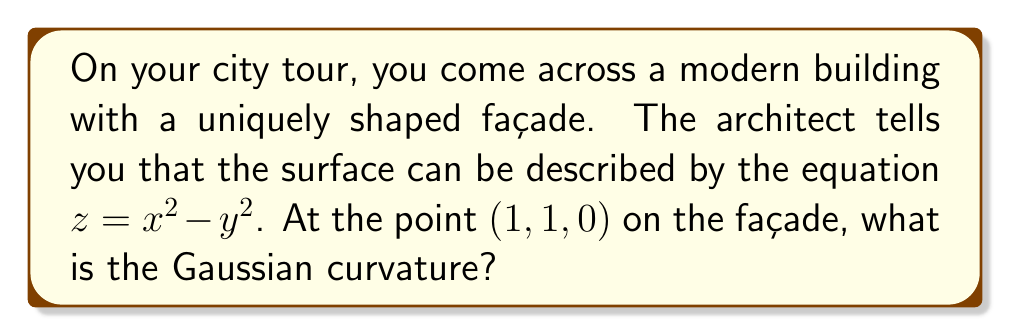Solve this math problem. To find the Gaussian curvature of the surface at the point (1, 1, 0), we'll follow these steps:

1) The surface is given by $z = x^2 - y^2$. Let's call this function $f(x,y)$.

2) We need to calculate the first and second partial derivatives:
   $f_x = 2x$
   $f_y = -2y$
   $f_{xx} = 2$
   $f_{yy} = -2$
   $f_{xy} = f_{yx} = 0$

3) The Gaussian curvature K is given by:
   $$K = \frac{f_{xx}f_{yy} - f_{xy}^2}{(1 + f_x^2 + f_y^2)^2}$$

4) Let's calculate the denominator first:
   At (1, 1, 0): $f_x = 2$ and $f_y = -2$
   $(1 + f_x^2 + f_y^2)^2 = (1 + 2^2 + (-2)^2)^2 = (1 + 4 + 4)^2 = 9^2 = 81$

5) Now the numerator:
   $f_{xx}f_{yy} - f_{xy}^2 = 2 \cdot (-2) - 0^2 = -4$

6) Therefore, the Gaussian curvature at (1, 1, 0) is:
   $$K = \frac{-4}{81} = -\frac{4}{81}$$
Answer: $-\frac{4}{81}$ 